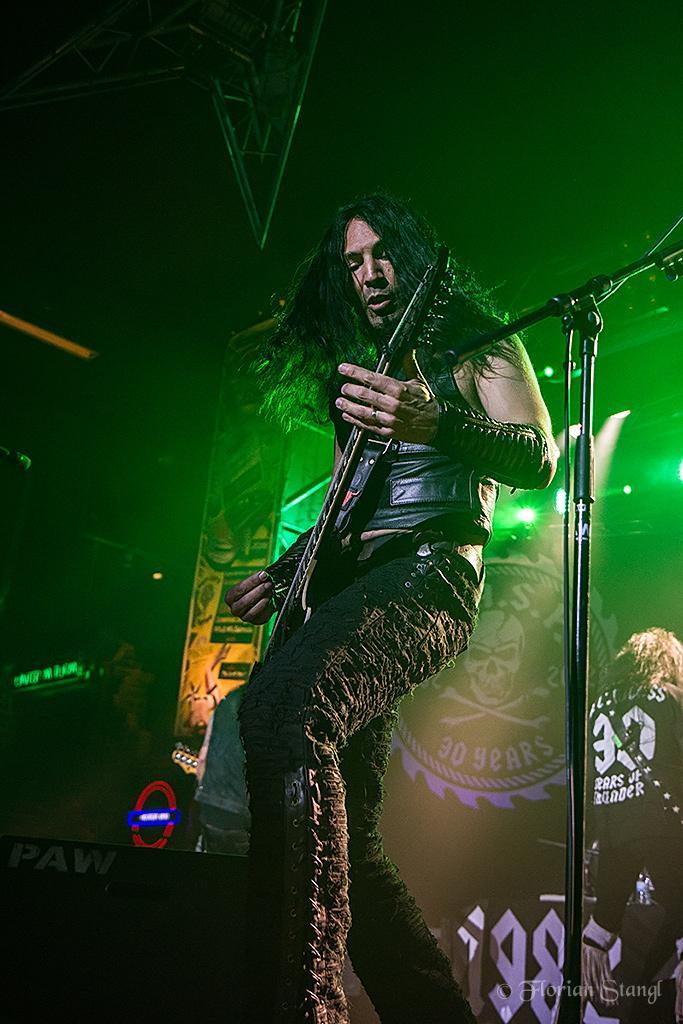Can you describe this image briefly? In this image, in the middle, we can see a man standing and playing a guitar in front of a microphone which is on the right side. In the background, we can see green color light and a hoarding, on the hoarding, we can see some text and some pictures. At the top, we can see black color, at the bottom, we can also see an electronic instrument. 